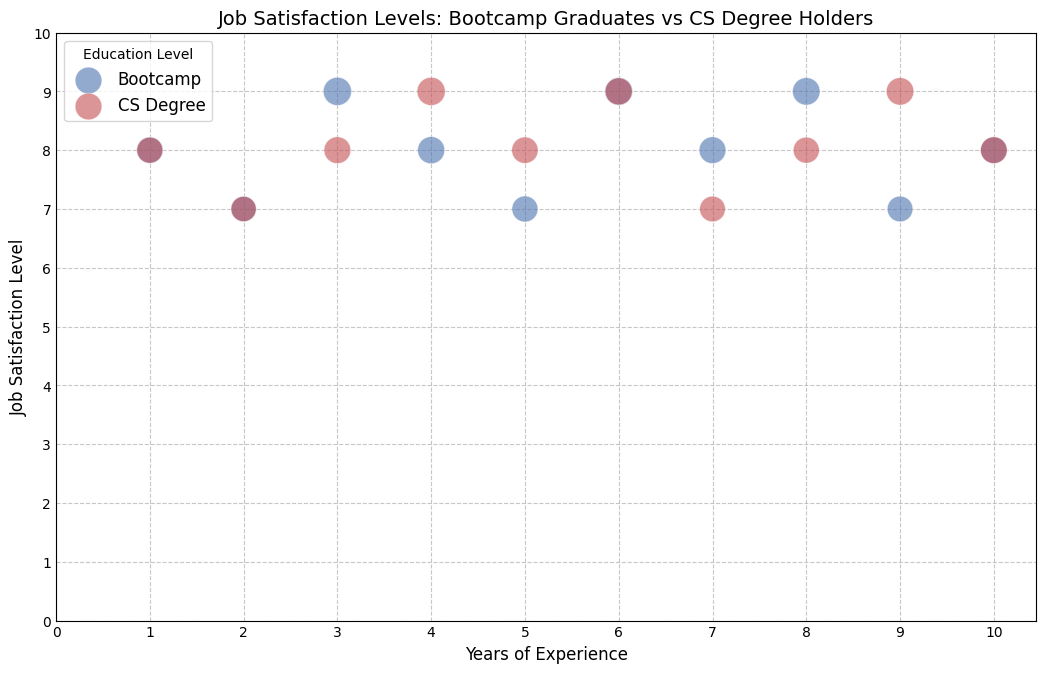What are the average job satisfaction levels for Bootcamp graduates and CS Degree holders? To find the average job satisfaction levels, add the individual satisfaction levels for each group and then divide by the number of data points in each group. For Bootcamp: (8 + 7 + 9 + 8 + 7 + 9 + 8 + 9 + 7 + 8) / 10 = 80 / 10 = 8. For CS Degree: (8 + 7 + 8 + 9 + 8 + 9 + 7 + 8 + 9 + 8) / 10 = 81 / 10 = 8.1
Answer: Bootcamp: 8, CS Degree: 8.1 Which education group has the highest satisfaction index for a given satisfaction level? By observing the size of the bubbles (which correspond to the satisfaction index) within each education group's satisfaction level, the Bootcamp group with a job satisfaction level of 9 has bubbles with indices of 4.0 and 4.1, while the CS Degree group has a highest index of 4.1 at the same level. Both groups have bubbles of similar size at high satisfaction levels but the Bootcamp group has consistently high indices at satisfaction level 9.
Answer: Bootcamp How do the job satisfaction levels of Bootcamp graduates with 6 years of experience compare to CS Degree holders with the same experience? By locating the bubbles corresponding to 6 years of experience, we see that both Bootcamp and CS Degree holders have job satisfaction levels of 9. Since the levels are the same, there is no difference.
Answer: Equal Is there a trend in the job satisfaction levels of Bootcamp graduates as their years of experience increase? By following the progression of job satisfaction levels of Bootcamp graduates along the x-axis (years of experience), we see that job satisfaction levels vary but stay relatively high, hovering around 7 to 9. Therefore, there is no clear upward or downward trend, but satisfaction levels tend to remain high.
Answer: High, no clear trend Which group has more bubbles with larger sizes, indicating higher satisfaction indices? By inspecting the figure, Bootcamp graduates have more bubbles with larger sizes (e.g., indices 4.0 and 4.1), whereas CS Degree holders have fewer large bubbles. Thus, Bootcamp graduates have more instances of higher satisfaction indices.
Answer: Bootcamp 